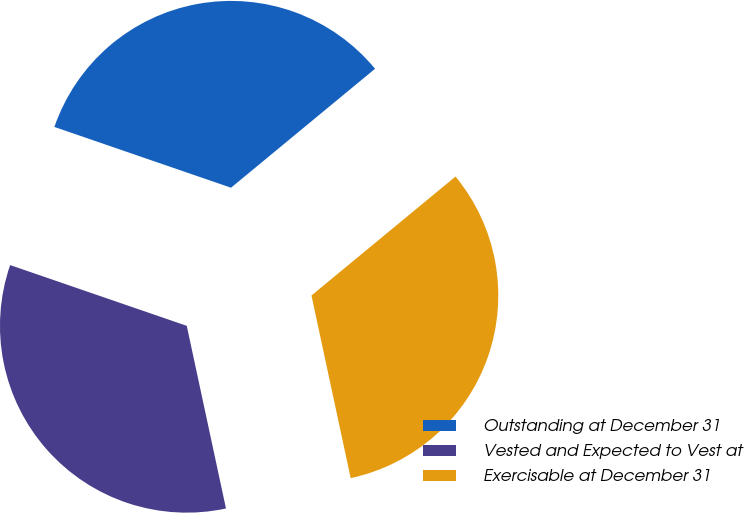Convert chart to OTSL. <chart><loc_0><loc_0><loc_500><loc_500><pie_chart><fcel>Outstanding at December 31<fcel>Vested and Expected to Vest at<fcel>Exercisable at December 31<nl><fcel>33.74%<fcel>33.64%<fcel>32.62%<nl></chart> 